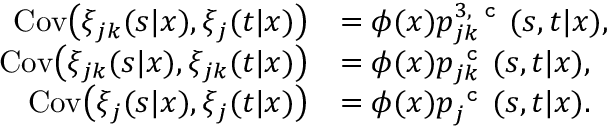<formula> <loc_0><loc_0><loc_500><loc_500>\begin{array} { r l } { C o v \left ( \xi _ { j k } ( s | x ) , \xi _ { j } ( t | x ) \right ) } & { = \phi ( x ) p _ { j k } ^ { 3 , c } ( s , t | x ) , } \\ { C o v \left ( \xi _ { j k } ( s | x ) , \xi _ { j k } ( t | x ) \right ) } & { = \phi ( x ) p _ { j k } ^ { c } ( s , t | x ) , } \\ { C o v \left ( \xi _ { j } ( s | x ) , \xi _ { j } ( t | x ) \right ) } & { = \phi ( x ) p _ { j } ^ { c } ( s , t | x ) . } \end{array}</formula> 